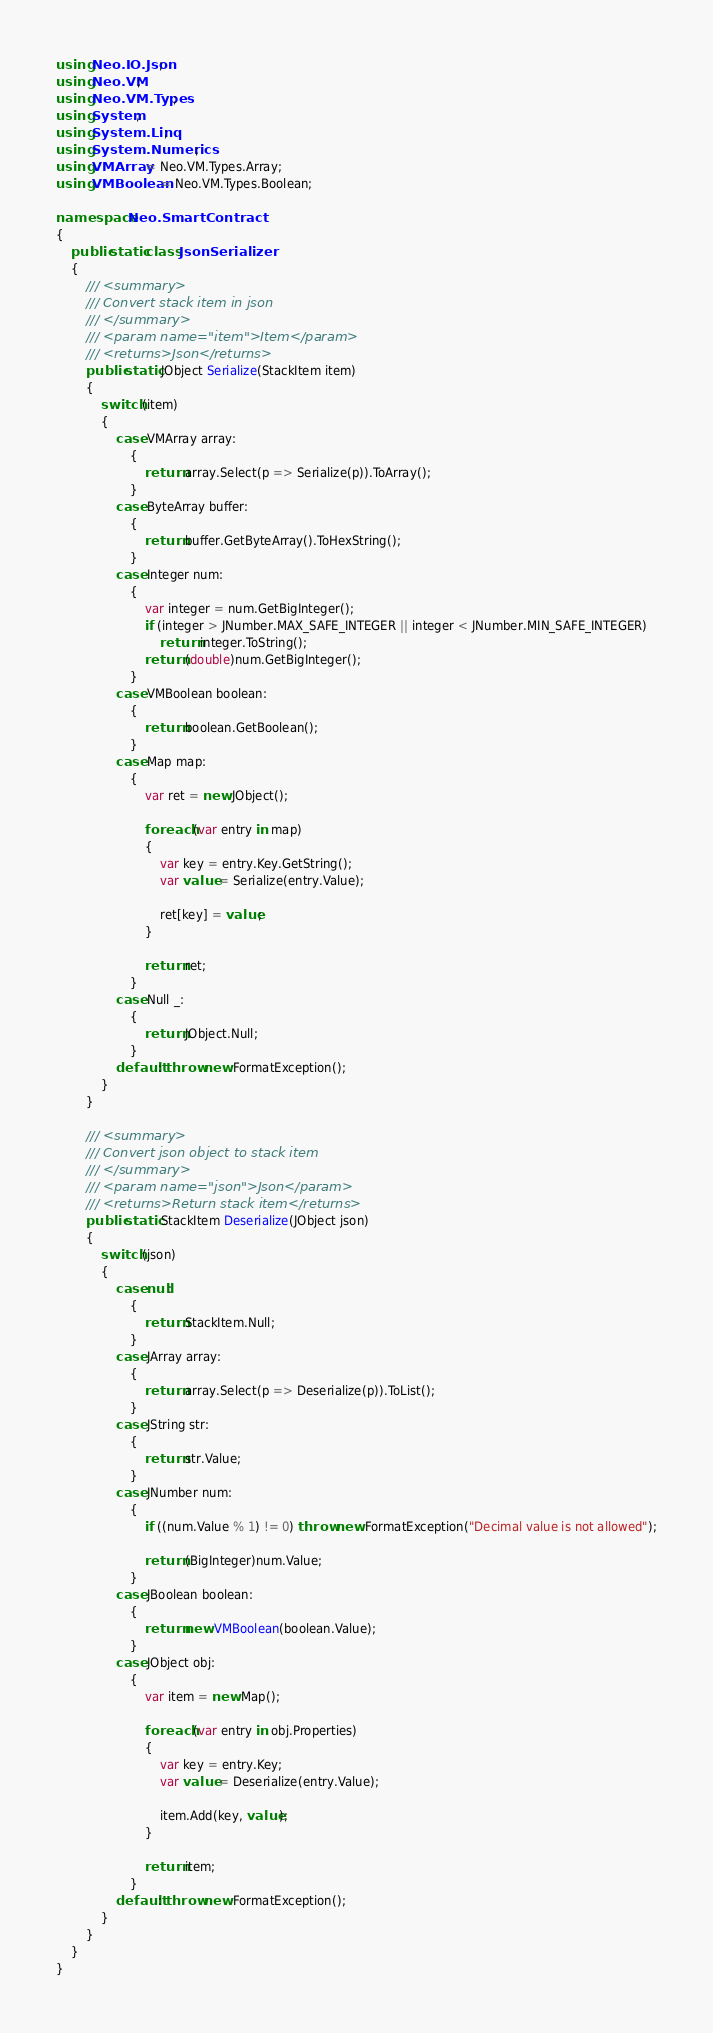<code> <loc_0><loc_0><loc_500><loc_500><_C#_>using Neo.IO.Json;
using Neo.VM;
using Neo.VM.Types;
using System;
using System.Linq;
using System.Numerics;
using VMArray = Neo.VM.Types.Array;
using VMBoolean = Neo.VM.Types.Boolean;

namespace Neo.SmartContract
{
    public static class JsonSerializer
    {
        /// <summary>
        /// Convert stack item in json
        /// </summary>
        /// <param name="item">Item</param>
        /// <returns>Json</returns>
        public static JObject Serialize(StackItem item)
        {
            switch (item)
            {
                case VMArray array:
                    {
                        return array.Select(p => Serialize(p)).ToArray();
                    }
                case ByteArray buffer:
                    {
                        return buffer.GetByteArray().ToHexString();
                    }
                case Integer num:
                    {
                        var integer = num.GetBigInteger();
                        if (integer > JNumber.MAX_SAFE_INTEGER || integer < JNumber.MIN_SAFE_INTEGER)
                            return integer.ToString();
                        return (double)num.GetBigInteger();
                    }
                case VMBoolean boolean:
                    {
                        return boolean.GetBoolean();
                    }
                case Map map:
                    {
                        var ret = new JObject();

                        foreach (var entry in map)
                        {
                            var key = entry.Key.GetString();
                            var value = Serialize(entry.Value);

                            ret[key] = value;
                        }

                        return ret;
                    }
                case Null _:
                    {
                        return JObject.Null;
                    }
                default: throw new FormatException();
            }
        }

        /// <summary>
        /// Convert json object to stack item
        /// </summary>
        /// <param name="json">Json</param>
        /// <returns>Return stack item</returns>
        public static StackItem Deserialize(JObject json)
        {
            switch (json)
            {
                case null:
                    {
                        return StackItem.Null;
                    }
                case JArray array:
                    {
                        return array.Select(p => Deserialize(p)).ToList();
                    }
                case JString str:
                    {
                        return str.Value;
                    }
                case JNumber num:
                    {
                        if ((num.Value % 1) != 0) throw new FormatException("Decimal value is not allowed");

                        return (BigInteger)num.Value;
                    }
                case JBoolean boolean:
                    {
                        return new VMBoolean(boolean.Value);
                    }
                case JObject obj:
                    {
                        var item = new Map();

                        foreach (var entry in obj.Properties)
                        {
                            var key = entry.Key;
                            var value = Deserialize(entry.Value);

                            item.Add(key, value);
                        }

                        return item;
                    }
                default: throw new FormatException();
            }
        }
    }
}
</code> 